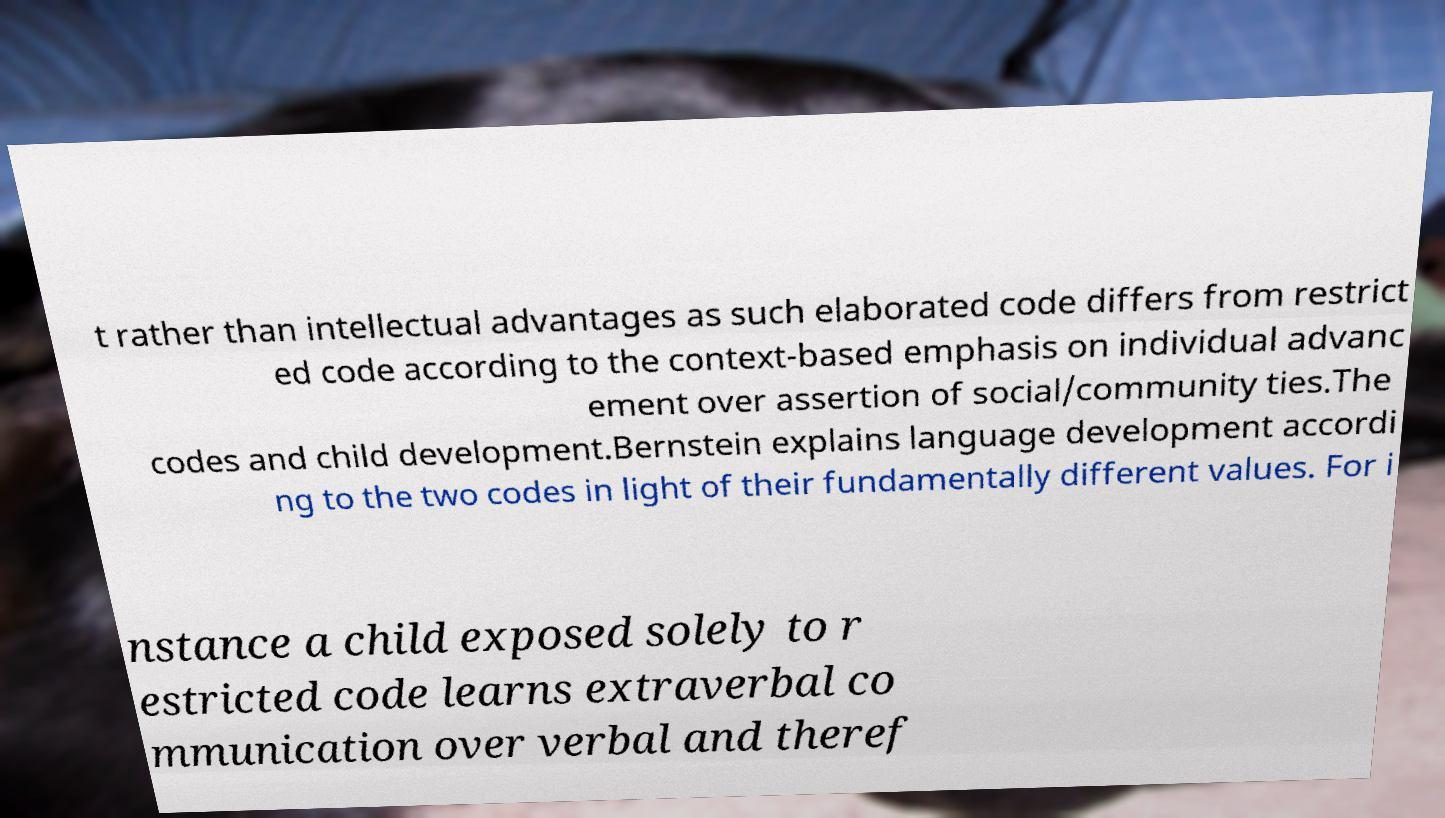What messages or text are displayed in this image? I need them in a readable, typed format. t rather than intellectual advantages as such elaborated code differs from restrict ed code according to the context-based emphasis on individual advanc ement over assertion of social/community ties.The codes and child development.Bernstein explains language development accordi ng to the two codes in light of their fundamentally different values. For i nstance a child exposed solely to r estricted code learns extraverbal co mmunication over verbal and theref 